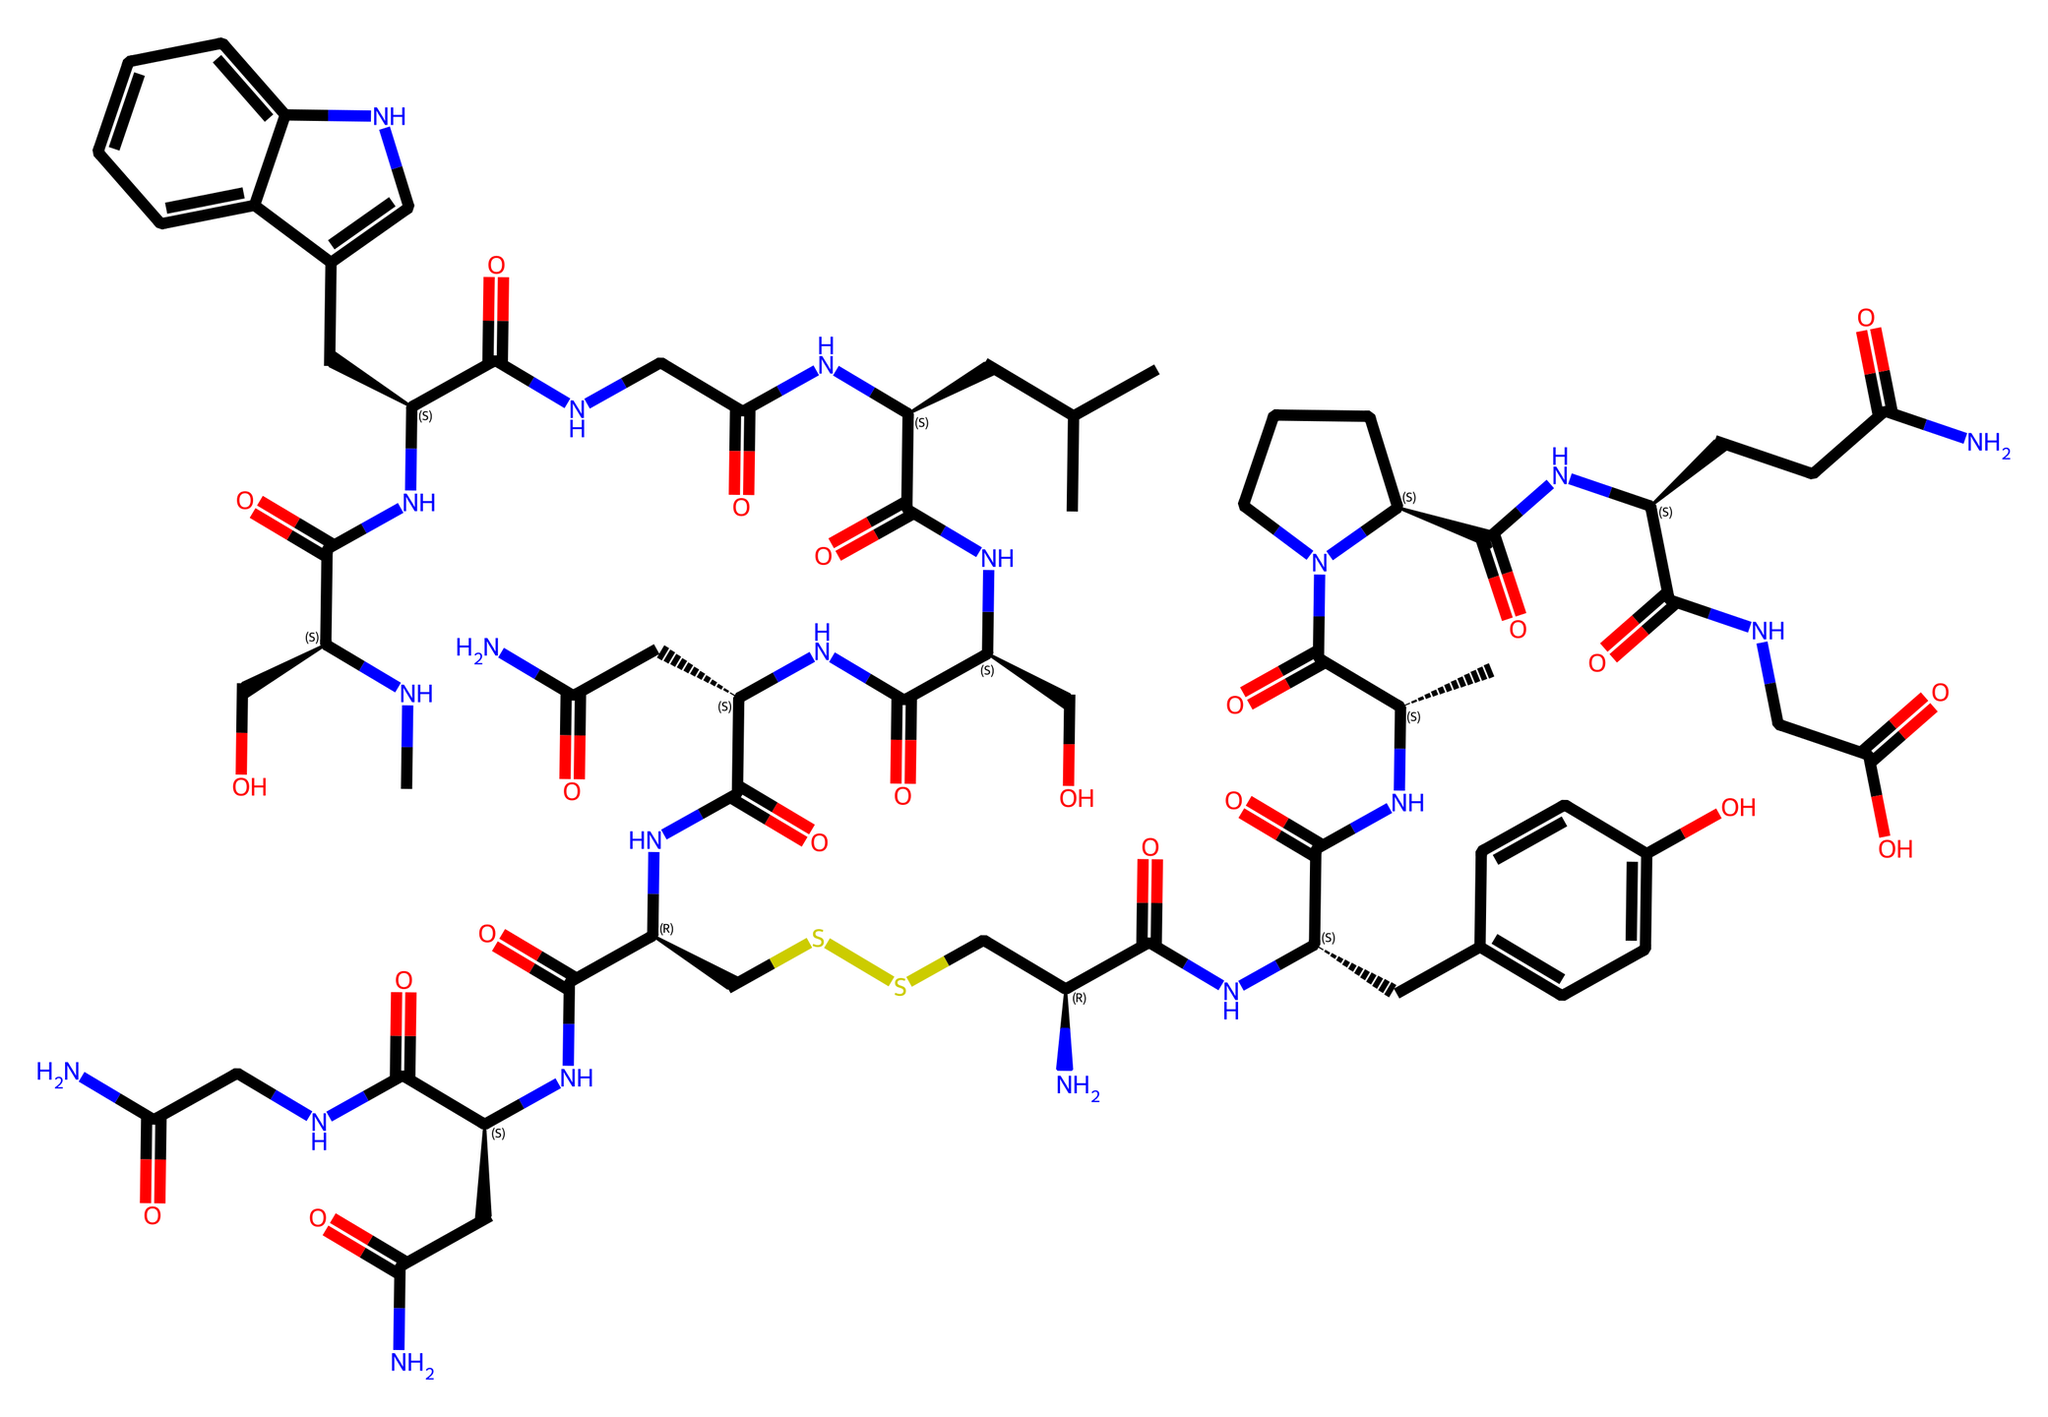What is the molecular formula of oxytocin? By analyzing the provided SMILES representation, we can calculate the total number of different atoms present. The main atoms in this structure include carbon (C), hydrogen (H), nitrogen (N), oxygen (O), and sulfur (S). By counting each type of atom from the SMILES, we find the molecular formula, which reveals the ratio of atoms present.
Answer: C43H66N12O12S2 How many nitrogen atoms are in oxytocin? The SMILES notation contains multiple instances of “N,” indicating the presence of nitrogen atoms. By carefully scanning the structure, we count all "N" symbols, ultimately determining the total number of nitrogen atoms in the molecule.
Answer: 12 What kind of bonding is primarily present in oxytocin? Examining the SMILES reveals several functional groups, including amide and disulfide linkages. The presence of nitrogen and sulfur atoms, as well as carbon chains, indicates that this molecule primarily features both single and double bonds typical in amide bonds and a disulfide bond, which connects two sulfur atoms.
Answer: covalent bonding Which aromatic ring is present in the molecular structure? By looking closely at the chemical structure in the SMILES representation, we identify the segment “Cc1ccc(O)cc1,” which corresponds to a benzene ring structure due to the inclusion of alternating double bonds and the presence of an -OH group (hydroxyl) attached. This indicates it is a phenolic ring component of oxytocin.
Answer: phenolic ring How many unique functional groups are identified in oxytocin? Upon examining the structure, we identify various functional groups, such as amides, a phenol (-OH), and a disulfide (S-S) bond. Each distinct type of functional group contributes to the molecule's properties, reflecting multiple chemistry principles. After careful identification, we conclude that there are three unique functional groups within the chemical structure.
Answer: three What is the significance of the sulfur atoms in oxytocin? The sulfur atoms (seen in the disulfide bond represented by "SS") play a crucial role by facilitating the three-dimensional structure and stability of the oxytocin molecule. Disulfide bridges are important for the biological activity of peptide hormones, including oxytocin, as they influence the molecule's conformation.
Answer: stability and activity 